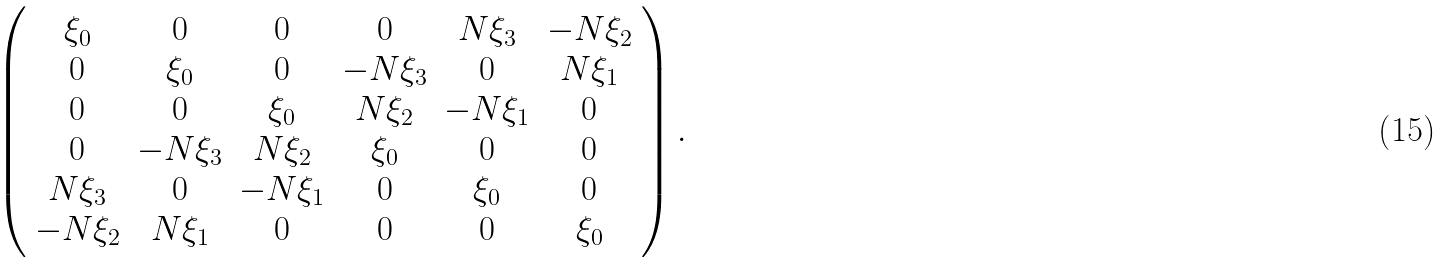<formula> <loc_0><loc_0><loc_500><loc_500>\left ( \begin{array} { c c c c c c } \xi _ { 0 } & 0 & 0 & 0 & N \xi _ { 3 } & - N \xi _ { 2 } \\ 0 & \xi _ { 0 } & 0 & - N \xi _ { 3 } & 0 & N \xi _ { 1 } \\ 0 & 0 & \xi _ { 0 } & N \xi _ { 2 } & - N \xi _ { 1 } & 0 \\ 0 & - N \xi _ { 3 } & N \xi _ { 2 } & \xi _ { 0 } & 0 & 0 \\ N \xi _ { 3 } & 0 & - N \xi _ { 1 } & 0 & \xi _ { 0 } & 0 \\ - N \xi _ { 2 } & N \xi _ { 1 } & 0 & 0 & 0 & \xi _ { 0 } \end{array} \right ) .</formula> 